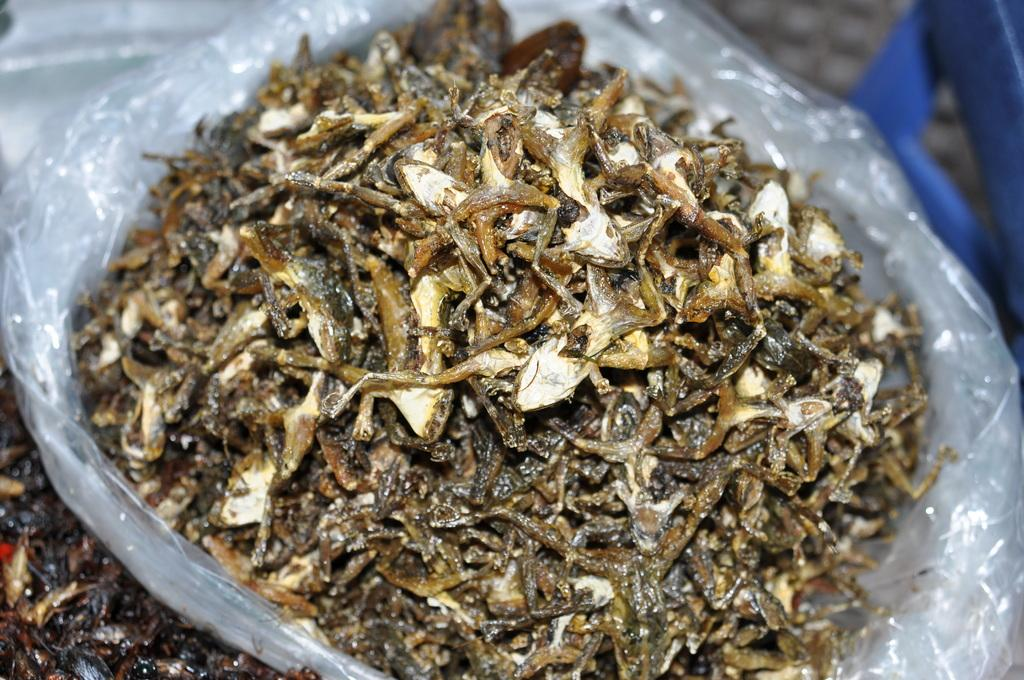What type of food is visible in the image? There are dried fishes in the image. How are the dried fishes being stored or protected? The dried fishes are in a cover. Can you make an assumption about the time of day when the image was taken? The image was likely taken during the day, as there is no indication of darkness or artificial lighting. What type of star can be seen in the image? There is no star visible in the image, as it features dried fishes in a cover. What type of battle is taking place in the image? There is no battle present in the image; it features dried fishes in a cover. 